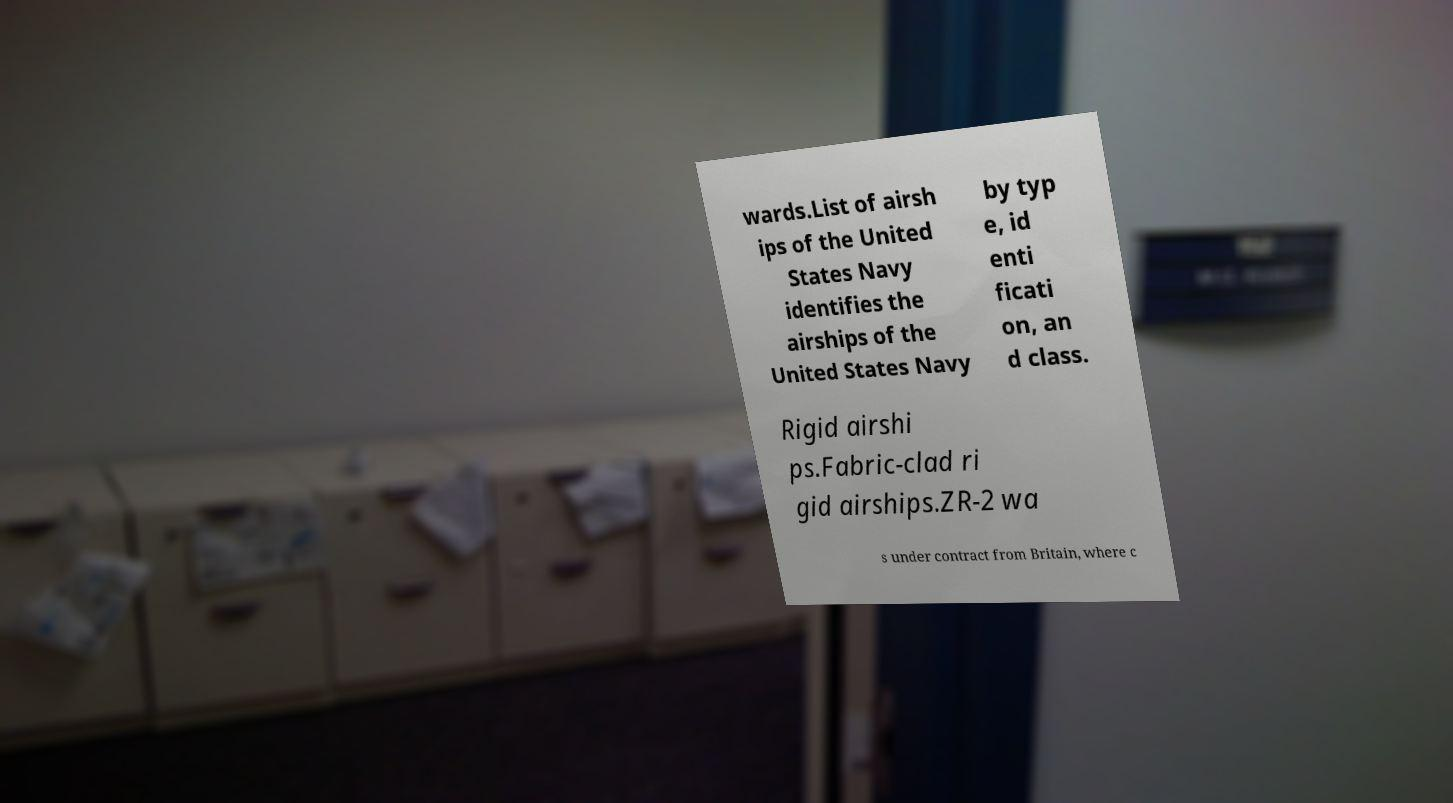Can you accurately transcribe the text from the provided image for me? wards.List of airsh ips of the United States Navy identifies the airships of the United States Navy by typ e, id enti ficati on, an d class. Rigid airshi ps.Fabric-clad ri gid airships.ZR-2 wa s under contract from Britain, where c 